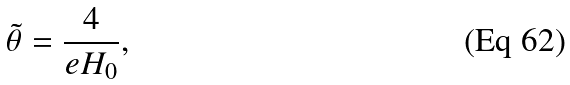Convert formula to latex. <formula><loc_0><loc_0><loc_500><loc_500>\tilde { \theta } = \frac { 4 } { e H _ { 0 } } ,</formula> 